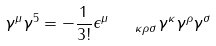Convert formula to latex. <formula><loc_0><loc_0><loc_500><loc_500>\gamma ^ { \mu } \gamma ^ { 5 } = - \frac { 1 } { 3 ! } \epsilon _ { \quad \kappa \rho \sigma } ^ { \mu } \gamma ^ { \kappa } \gamma ^ { \rho } \gamma ^ { \sigma }</formula> 